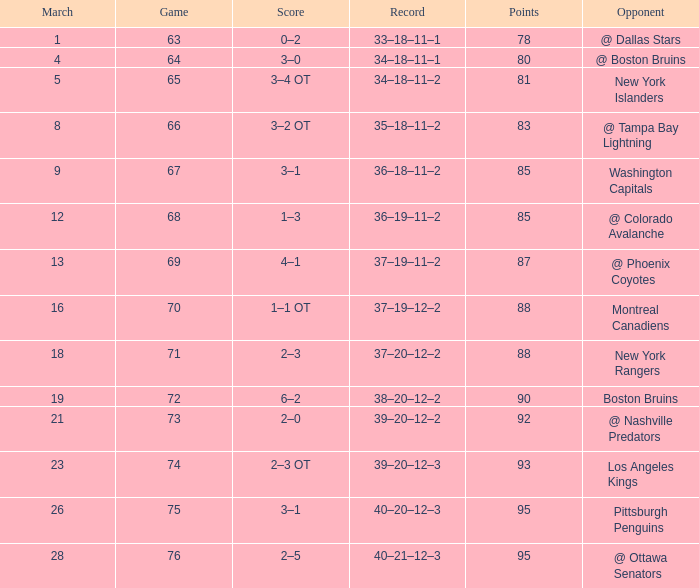Which Points have an Opponent of new york islanders, and a Game smaller than 65? None. 